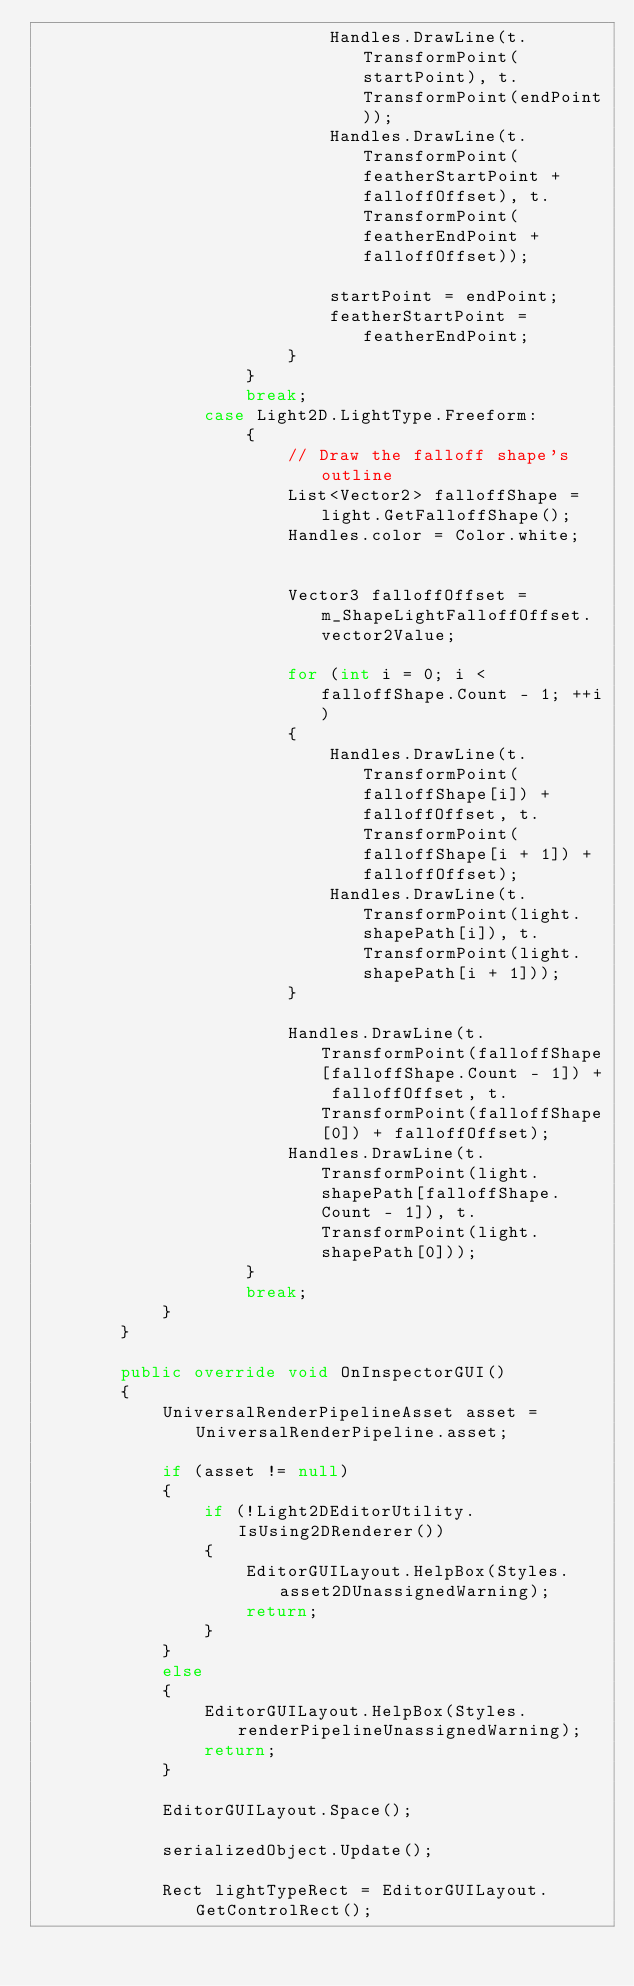<code> <loc_0><loc_0><loc_500><loc_500><_C#_>                            Handles.DrawLine(t.TransformPoint(startPoint), t.TransformPoint(endPoint));
                            Handles.DrawLine(t.TransformPoint(featherStartPoint + falloffOffset), t.TransformPoint(featherEndPoint + falloffOffset));

                            startPoint = endPoint;
                            featherStartPoint = featherEndPoint;
                        }
                    }
                    break;
                case Light2D.LightType.Freeform:
                    {
                        // Draw the falloff shape's outline
                        List<Vector2> falloffShape = light.GetFalloffShape();
                        Handles.color = Color.white;


                        Vector3 falloffOffset = m_ShapeLightFalloffOffset.vector2Value;

                        for (int i = 0; i < falloffShape.Count - 1; ++i)
                        {
                            Handles.DrawLine(t.TransformPoint(falloffShape[i]) + falloffOffset, t.TransformPoint(falloffShape[i + 1]) + falloffOffset);
                            Handles.DrawLine(t.TransformPoint(light.shapePath[i]), t.TransformPoint(light.shapePath[i + 1]));
                        }

                        Handles.DrawLine(t.TransformPoint(falloffShape[falloffShape.Count - 1]) + falloffOffset, t.TransformPoint(falloffShape[0]) + falloffOffset);
                        Handles.DrawLine(t.TransformPoint(light.shapePath[falloffShape.Count - 1]), t.TransformPoint(light.shapePath[0]));
                    }
                    break;
            }
        }

        public override void OnInspectorGUI()
        {
            UniversalRenderPipelineAsset asset = UniversalRenderPipeline.asset;

            if (asset != null)
            {
                if (!Light2DEditorUtility.IsUsing2DRenderer())
                {
                    EditorGUILayout.HelpBox(Styles.asset2DUnassignedWarning);
                    return;
                }
            }
            else
            {
                EditorGUILayout.HelpBox(Styles.renderPipelineUnassignedWarning);
                return;
            }

            EditorGUILayout.Space();

            serializedObject.Update();

            Rect lightTypeRect = EditorGUILayout.GetControlRect();</code> 